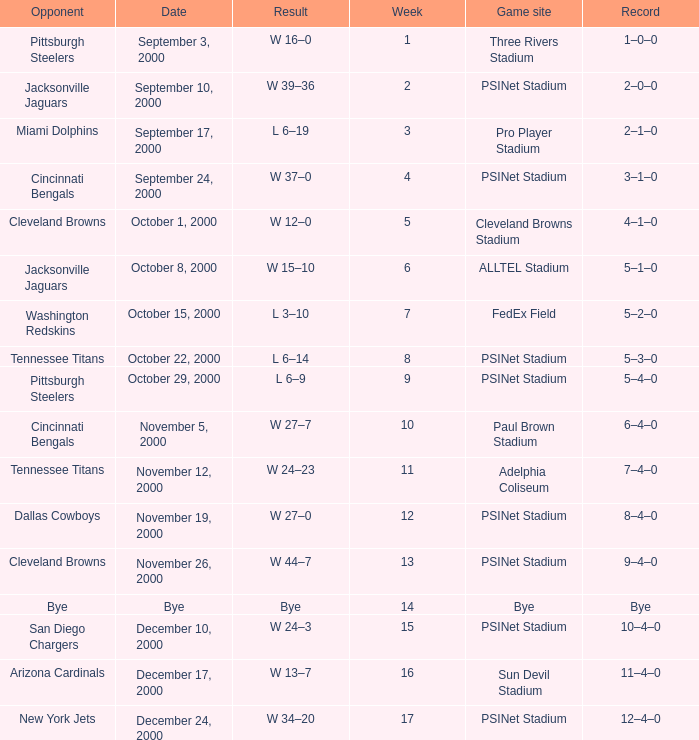Could you parse the entire table? {'header': ['Opponent', 'Date', 'Result', 'Week', 'Game site', 'Record'], 'rows': [['Pittsburgh Steelers', 'September 3, 2000', 'W 16–0', '1', 'Three Rivers Stadium', '1–0–0'], ['Jacksonville Jaguars', 'September 10, 2000', 'W 39–36', '2', 'PSINet Stadium', '2–0–0'], ['Miami Dolphins', 'September 17, 2000', 'L 6–19', '3', 'Pro Player Stadium', '2–1–0'], ['Cincinnati Bengals', 'September 24, 2000', 'W 37–0', '4', 'PSINet Stadium', '3–1–0'], ['Cleveland Browns', 'October 1, 2000', 'W 12–0', '5', 'Cleveland Browns Stadium', '4–1–0'], ['Jacksonville Jaguars', 'October 8, 2000', 'W 15–10', '6', 'ALLTEL Stadium', '5–1–0'], ['Washington Redskins', 'October 15, 2000', 'L 3–10', '7', 'FedEx Field', '5–2–0'], ['Tennessee Titans', 'October 22, 2000', 'L 6–14', '8', 'PSINet Stadium', '5–3–0'], ['Pittsburgh Steelers', 'October 29, 2000', 'L 6–9', '9', 'PSINet Stadium', '5–4–0'], ['Cincinnati Bengals', 'November 5, 2000', 'W 27–7', '10', 'Paul Brown Stadium', '6–4–0'], ['Tennessee Titans', 'November 12, 2000', 'W 24–23', '11', 'Adelphia Coliseum', '7–4–0'], ['Dallas Cowboys', 'November 19, 2000', 'W 27–0', '12', 'PSINet Stadium', '8–4–0'], ['Cleveland Browns', 'November 26, 2000', 'W 44–7', '13', 'PSINet Stadium', '9–4–0'], ['Bye', 'Bye', 'Bye', '14', 'Bye', 'Bye'], ['San Diego Chargers', 'December 10, 2000', 'W 24–3', '15', 'PSINet Stadium', '10–4–0'], ['Arizona Cardinals', 'December 17, 2000', 'W 13–7', '16', 'Sun Devil Stadium', '11–4–0'], ['New York Jets', 'December 24, 2000', 'W 34–20', '17', 'PSINet Stadium', '12–4–0']]} What's the record after week 12 with a game site of bye? Bye. 